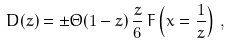Convert formula to latex. <formula><loc_0><loc_0><loc_500><loc_500>D ( z ) = \pm \Theta ( 1 - z ) \, \frac { z } { 6 } \, F \left ( x = \frac { 1 } { z } \right ) \, ,</formula> 